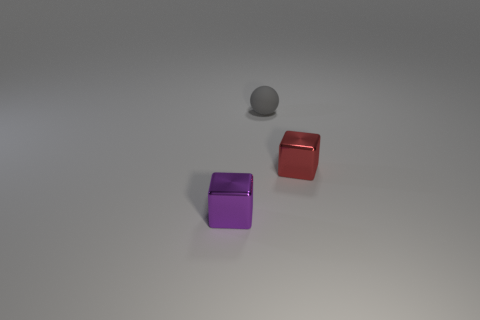There is a purple thing; is it the same size as the shiny block to the right of the purple block?
Your answer should be very brief. Yes. What number of other objects are the same material as the tiny red object?
Make the answer very short. 1. Is there any other thing that is the same shape as the tiny gray matte thing?
Offer a very short reply. No. The tiny shiny thing that is in front of the small metallic thing that is right of the thing behind the tiny red metallic object is what color?
Offer a terse response. Purple. There is a thing that is both right of the purple block and in front of the gray sphere; what shape is it?
Your answer should be compact. Cube. The tiny cube that is in front of the small metal thing that is behind the purple object is what color?
Offer a terse response. Purple. What is the shape of the metallic object that is right of the tiny object that is in front of the metal thing that is behind the small purple thing?
Make the answer very short. Cube. What number of tiny metal blocks are the same color as the tiny rubber object?
Offer a very short reply. 0. What material is the purple thing?
Provide a short and direct response. Metal. Are the cube that is behind the purple metallic cube and the gray thing made of the same material?
Keep it short and to the point. No. 